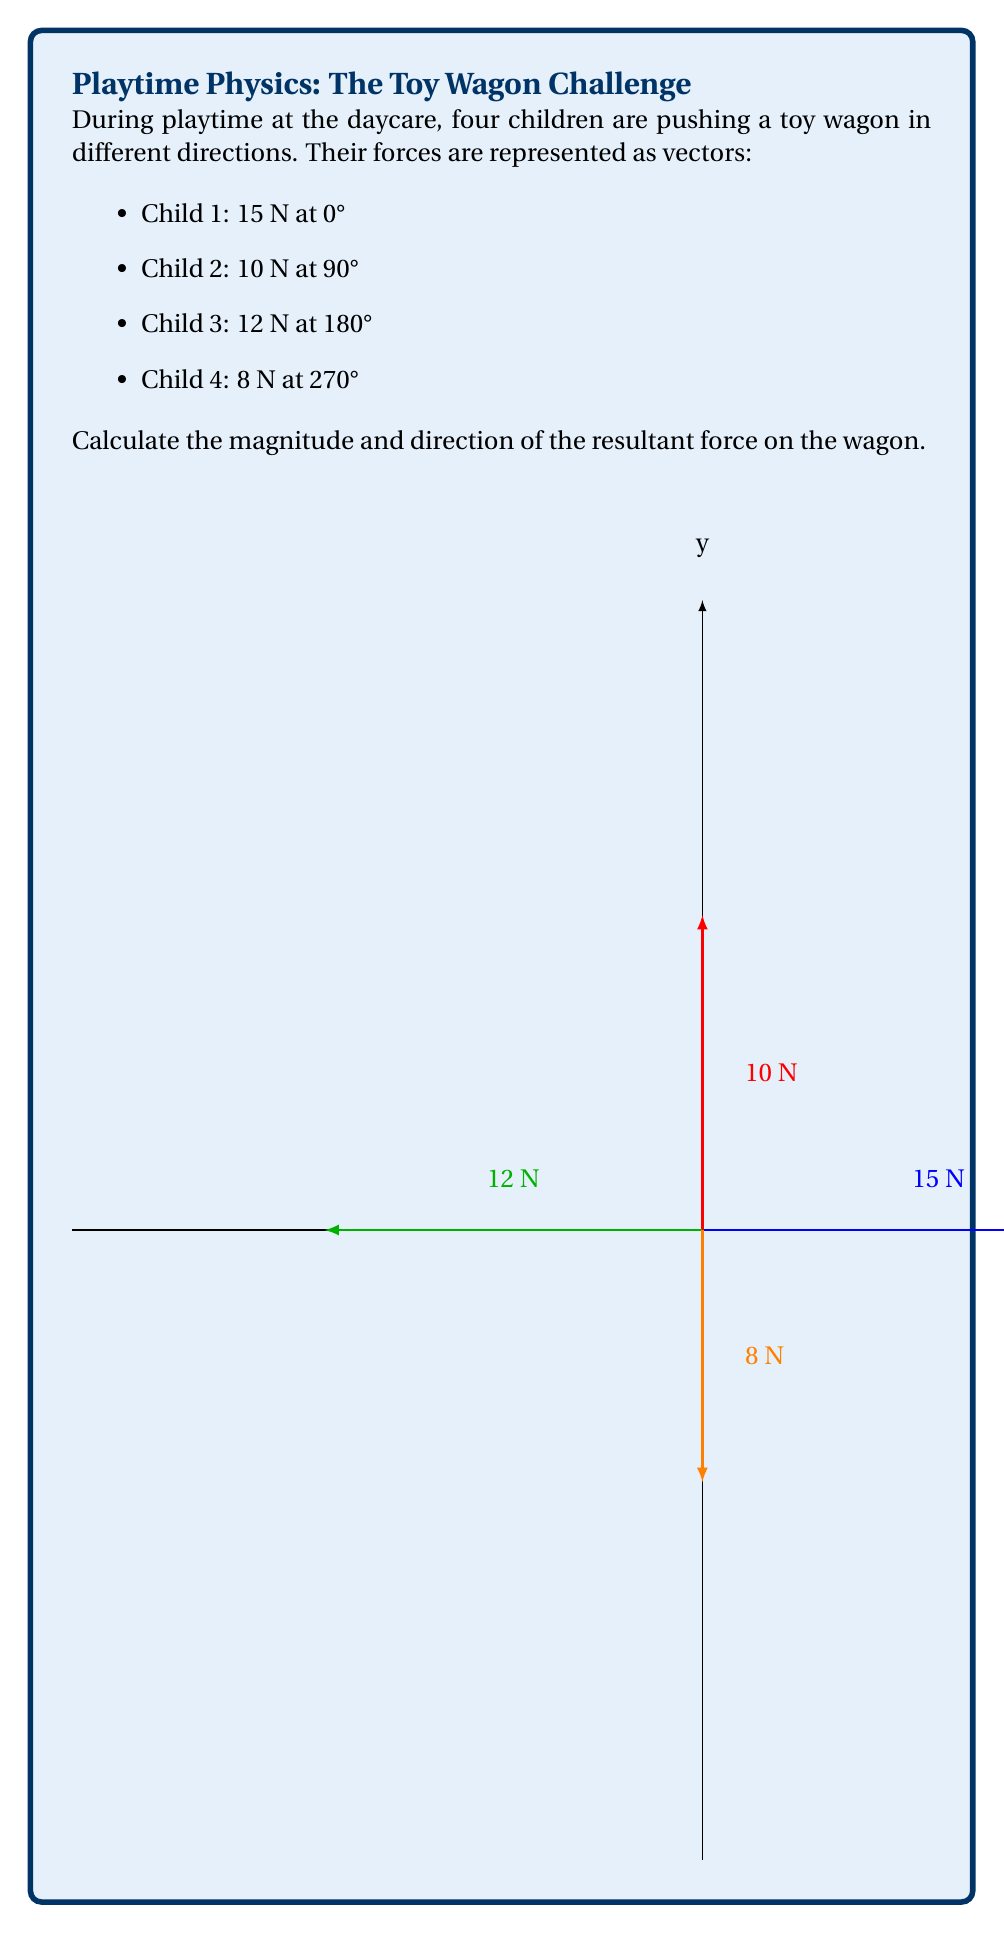Help me with this question. To solve this problem, we'll use vector addition and the rectangular coordinate system:

1) First, break down each force into its x and y components:

   Child 1: $F_{x1} = 15 \cos(0°) = 15$ N,  $F_{y1} = 15 \sin(0°) = 0$ N
   Child 2: $F_{x2} = 10 \cos(90°) = 0$ N, $F_{y2} = 10 \sin(90°) = 10$ N
   Child 3: $F_{x3} = 12 \cos(180°) = -12$ N, $F_{y3} = 12 \sin(180°) = 0$ N
   Child 4: $F_{x4} = 8 \cos(270°) = 0$ N, $F_{y4} = 8 \sin(270°) = -8$ N

2) Sum the x and y components separately:

   $F_x = F_{x1} + F_{x2} + F_{x3} + F_{x4} = 15 + 0 + (-12) + 0 = 3$ N
   $F_y = F_{y1} + F_{y2} + F_{y3} + F_{y4} = 0 + 10 + 0 + (-8) = 2$ N

3) Calculate the magnitude of the resultant force using the Pythagorean theorem:

   $F_R = \sqrt{F_x^2 + F_y^2} = \sqrt{3^2 + 2^2} = \sqrt{13} \approx 3.61$ N

4) Calculate the direction of the resultant force using the arctangent function:

   $\theta = \tan^{-1}(\frac{F_y}{F_x}) = \tan^{-1}(\frac{2}{3}) \approx 33.69°$

Therefore, the resultant force has a magnitude of approximately 3.61 N and acts at an angle of approximately 33.69° from the positive x-axis.
Answer: $3.61$ N at $33.69°$ 